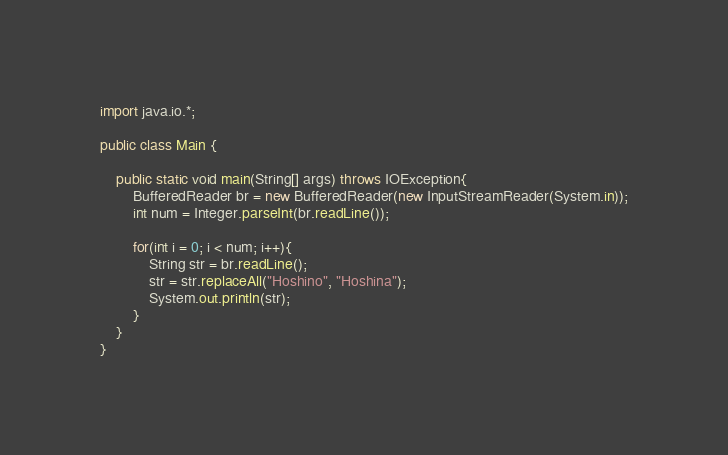<code> <loc_0><loc_0><loc_500><loc_500><_Java_>import java.io.*;

public class Main {

	public static void main(String[] args) throws IOException{
		BufferedReader br = new BufferedReader(new InputStreamReader(System.in));
		int num = Integer.parseInt(br.readLine());
		
		for(int i = 0; i < num; i++){
			String str = br.readLine();
			str = str.replaceAll("Hoshino", "Hoshina");
			System.out.println(str);
		}
	}
}</code> 